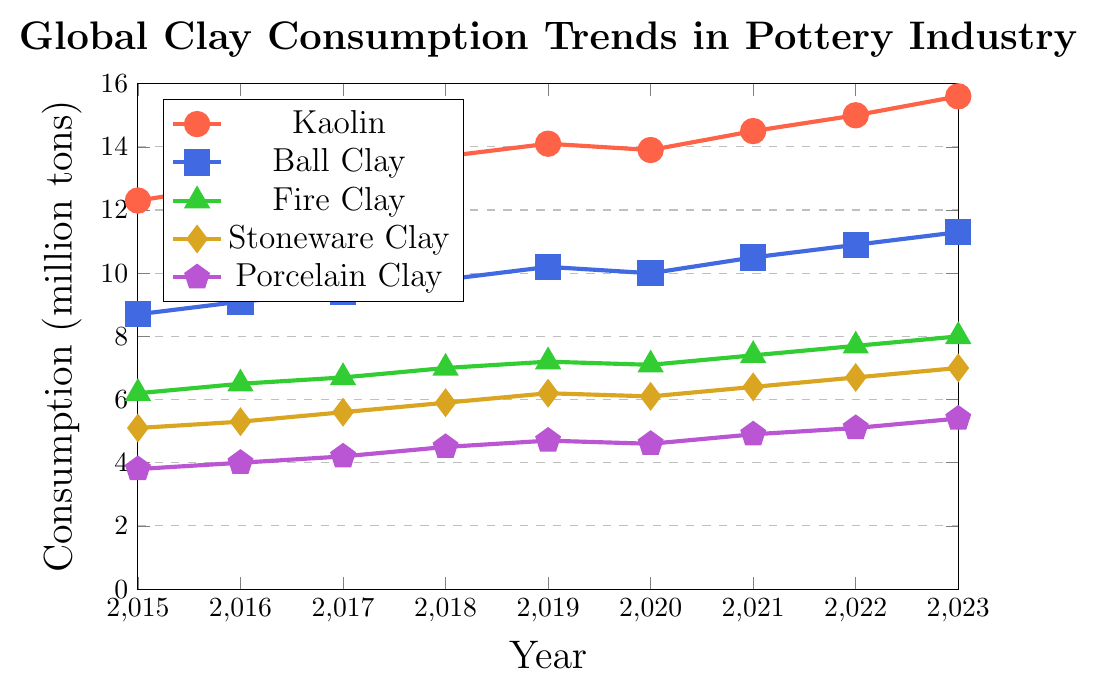What is the overall trend in Kaolin consumption from 2015 to 2023? The Kaolin consumption shows a general upward trend from 12.3 million tons in 2015 to 15.6 million tons in 2023. There is a slight dip in 2020, but the overall trend is increasing.
Answer: Increasing Which type of clay saw the smallest increase in consumption from 2015 to 2023? Fire Clay consumption increased from 6.2 million tons in 2015 to 8.0 million tons in 2023, which is a smaller increase compared to others. Stoneware Clay increased from 5.1 to 7.0 million tons and Porcelain Clay from 3.8 to 5.4 million tons.
Answer: Fire Clay In which year did Porcelain Clay consumption surpass 4.0 million tons for the first time? By examining the figure, Porcelain Clay consumption surpassed 4.0 million tons between 2016 and 2017. It hit 4.2 million tons in 2017.
Answer: 2017 How did Ball Clay consumption change from 2019 to 2020? Ball Clay consumption slightly decreased from 10.2 million tons in 2019 to 10.0 million tons in 2020.
Answer: Decreased Which type of clay had the largest increase in consumption between 2020 and 2021? From the data, Kaolin consumption increased from 13.9 to 14.5 million tons between 2020 and 2021, which is the largest increase among all types of clay for that period.
Answer: Kaolin What was the total clay consumption for all types in 2023? Sum up the 2023 values: Kaolin (15.6) + Ball Clay (11.3) + Fire Clay (8.0) + Stoneware Clay (7.0) + Porcelain Clay (5.4) = 47.3 million tons.
Answer: 47.3 million tons Comparing 2016 data, which clay type had the highest consumption? In 2016, Kaolin had the highest consumption at 12.8 million tons.
Answer: Kaolin What is the difference in consumption between Kaolin and Fire Clay in 2023? The consumption of Kaolin in 2023 is 15.6 million tons, and Fire Clay is 8.0 million tons. The difference is 15.6 - 8.0 = 7.6 million tons.
Answer: 7.6 million tons Which clay type shows the steadiest increase in consumption over the period? Ball Clay consumption increases gradually and steadily each year from 8.7 million tons in 2015 to 11.3 million tons in 2023 without any dips or irregularities.
Answer: Ball Clay 